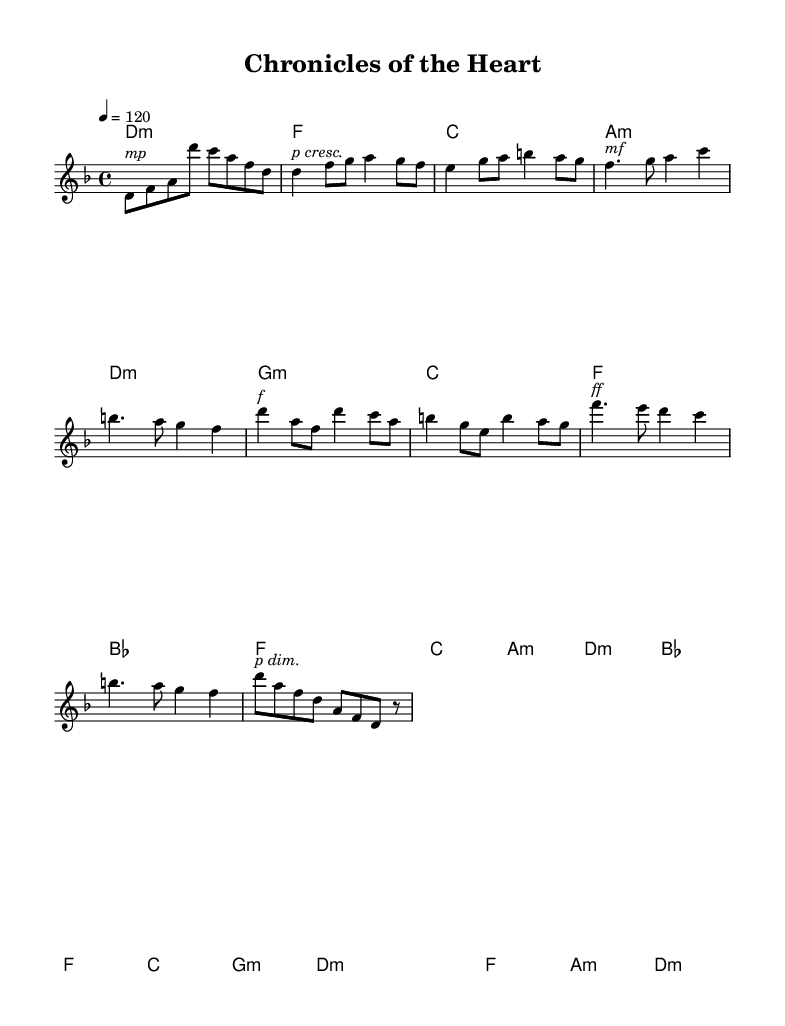What is the key signature of this music? The key signature is indicated by the symbol placed at the beginning of the staff. In this sheet music, there are no sharps or flats indicated, which means the key signature corresponds to A minor or C major. Since the piece is in D minor, the key signature includes one flat (B flat).
Answer: D minor What is the time signature of this music? The time signature is typically shown at the beginning of the staff, right after the key signature. It indicates how many beats are in each measure. In this case, the time signature is shown as 4/4, meaning there are four beats per measure.
Answer: 4/4 What is the tempo marking of the piece? The tempo is indicated at the beginning of the score, where it states "4 = 120." This specifies that there are 120 quarter note beats per minute, defining the speed of the music.
Answer: 120 How many sections are in the song structure based on the provided music? The analysis of the sheet music shows distinct sections labeled as Intro, Verse 1, Pre-Chorus, Chorus, Bridge, and Outro. By counting these sections, we find that there are six distinct structural components in the song.
Answer: Six What is the dynamic marking at the Chorus? The dynamic marking in music indicates how loud or soft the music should be played. In the Chorus, the dynamic marking is "f," meaning it should be played loudly.
Answer: f What kind of narrative structure is suggested in the song based on the sections? The presence of multiple sections such as Intro, Verses, Pre-Chorus, Chorus, Bridge, and Outro suggests a narrative structure typical in K-Pop where the story develops progressively through verses leading to a climax in the Chorus and resolving in the Outro.
Answer: Complex narrative structure What is the emotion conveyed in the Bridge according to the dynamics? The dynamic marking in the Bridge indicates "ff," which stands for fortissimo, suggesting a very loud and intense emotional expression. This typically conveys a heightened emotional state or a critical moment in the narrative.
Answer: Intense emotion 